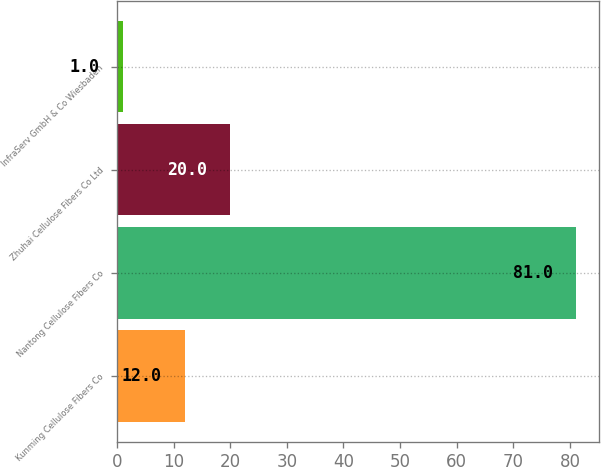<chart> <loc_0><loc_0><loc_500><loc_500><bar_chart><fcel>Kunming Cellulose Fibers Co<fcel>Nantong Cellulose Fibers Co<fcel>Zhuhai Cellulose Fibers Co Ltd<fcel>InfraServ GmbH & Co Wiesbaden<nl><fcel>12<fcel>81<fcel>20<fcel>1<nl></chart> 